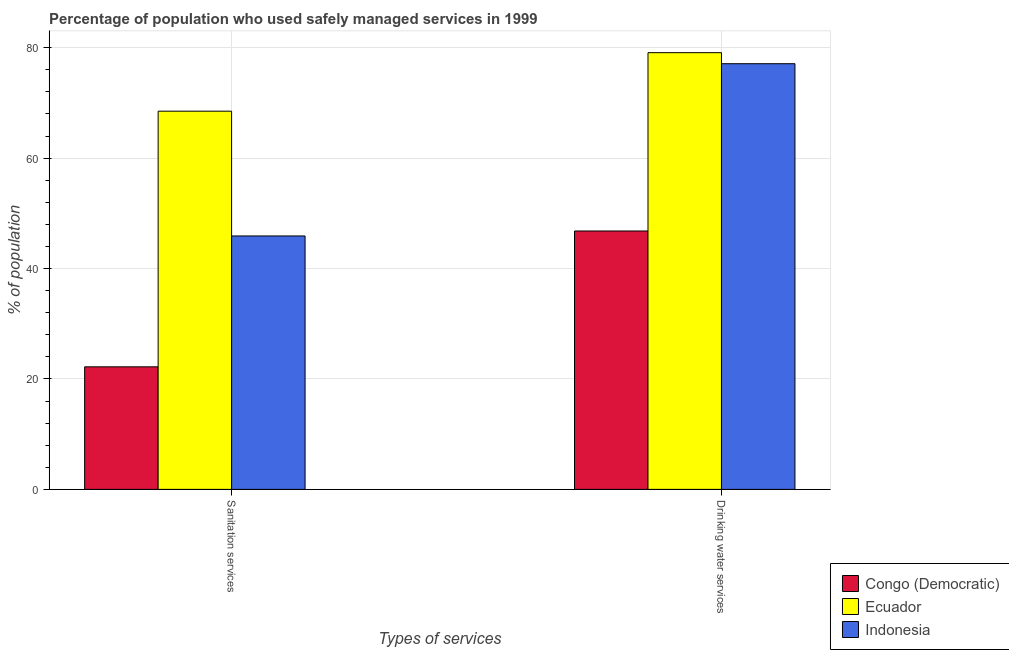How many different coloured bars are there?
Your response must be concise. 3. How many groups of bars are there?
Give a very brief answer. 2. Are the number of bars on each tick of the X-axis equal?
Ensure brevity in your answer.  Yes. What is the label of the 2nd group of bars from the left?
Offer a very short reply. Drinking water services. Across all countries, what is the maximum percentage of population who used drinking water services?
Give a very brief answer. 79.1. Across all countries, what is the minimum percentage of population who used sanitation services?
Offer a terse response. 22.2. In which country was the percentage of population who used drinking water services maximum?
Ensure brevity in your answer.  Ecuador. In which country was the percentage of population who used drinking water services minimum?
Give a very brief answer. Congo (Democratic). What is the total percentage of population who used sanitation services in the graph?
Keep it short and to the point. 136.6. What is the difference between the percentage of population who used sanitation services in Congo (Democratic) and that in Ecuador?
Offer a terse response. -46.3. What is the difference between the percentage of population who used drinking water services in Indonesia and the percentage of population who used sanitation services in Congo (Democratic)?
Ensure brevity in your answer.  54.9. What is the average percentage of population who used sanitation services per country?
Keep it short and to the point. 45.53. What is the difference between the percentage of population who used drinking water services and percentage of population who used sanitation services in Ecuador?
Keep it short and to the point. 10.6. In how many countries, is the percentage of population who used drinking water services greater than 36 %?
Ensure brevity in your answer.  3. What is the ratio of the percentage of population who used drinking water services in Congo (Democratic) to that in Ecuador?
Your answer should be very brief. 0.59. In how many countries, is the percentage of population who used drinking water services greater than the average percentage of population who used drinking water services taken over all countries?
Provide a succinct answer. 2. What does the 2nd bar from the right in Sanitation services represents?
Provide a succinct answer. Ecuador. How many bars are there?
Keep it short and to the point. 6. Are all the bars in the graph horizontal?
Give a very brief answer. No. How many countries are there in the graph?
Make the answer very short. 3. Does the graph contain any zero values?
Give a very brief answer. No. How many legend labels are there?
Provide a succinct answer. 3. How are the legend labels stacked?
Give a very brief answer. Vertical. What is the title of the graph?
Your answer should be very brief. Percentage of population who used safely managed services in 1999. What is the label or title of the X-axis?
Your response must be concise. Types of services. What is the label or title of the Y-axis?
Offer a very short reply. % of population. What is the % of population of Ecuador in Sanitation services?
Keep it short and to the point. 68.5. What is the % of population in Indonesia in Sanitation services?
Your response must be concise. 45.9. What is the % of population of Congo (Democratic) in Drinking water services?
Your answer should be very brief. 46.8. What is the % of population of Ecuador in Drinking water services?
Provide a short and direct response. 79.1. What is the % of population in Indonesia in Drinking water services?
Your answer should be compact. 77.1. Across all Types of services, what is the maximum % of population of Congo (Democratic)?
Give a very brief answer. 46.8. Across all Types of services, what is the maximum % of population of Ecuador?
Provide a succinct answer. 79.1. Across all Types of services, what is the maximum % of population in Indonesia?
Ensure brevity in your answer.  77.1. Across all Types of services, what is the minimum % of population in Ecuador?
Provide a succinct answer. 68.5. Across all Types of services, what is the minimum % of population of Indonesia?
Your answer should be compact. 45.9. What is the total % of population in Ecuador in the graph?
Provide a succinct answer. 147.6. What is the total % of population in Indonesia in the graph?
Your answer should be compact. 123. What is the difference between the % of population in Congo (Democratic) in Sanitation services and that in Drinking water services?
Keep it short and to the point. -24.6. What is the difference between the % of population in Ecuador in Sanitation services and that in Drinking water services?
Provide a short and direct response. -10.6. What is the difference between the % of population of Indonesia in Sanitation services and that in Drinking water services?
Keep it short and to the point. -31.2. What is the difference between the % of population of Congo (Democratic) in Sanitation services and the % of population of Ecuador in Drinking water services?
Your response must be concise. -56.9. What is the difference between the % of population in Congo (Democratic) in Sanitation services and the % of population in Indonesia in Drinking water services?
Your response must be concise. -54.9. What is the average % of population in Congo (Democratic) per Types of services?
Provide a short and direct response. 34.5. What is the average % of population in Ecuador per Types of services?
Your answer should be compact. 73.8. What is the average % of population in Indonesia per Types of services?
Make the answer very short. 61.5. What is the difference between the % of population of Congo (Democratic) and % of population of Ecuador in Sanitation services?
Offer a very short reply. -46.3. What is the difference between the % of population in Congo (Democratic) and % of population in Indonesia in Sanitation services?
Your answer should be very brief. -23.7. What is the difference between the % of population of Ecuador and % of population of Indonesia in Sanitation services?
Make the answer very short. 22.6. What is the difference between the % of population of Congo (Democratic) and % of population of Ecuador in Drinking water services?
Offer a terse response. -32.3. What is the difference between the % of population of Congo (Democratic) and % of population of Indonesia in Drinking water services?
Your response must be concise. -30.3. What is the difference between the % of population in Ecuador and % of population in Indonesia in Drinking water services?
Offer a very short reply. 2. What is the ratio of the % of population of Congo (Democratic) in Sanitation services to that in Drinking water services?
Offer a very short reply. 0.47. What is the ratio of the % of population in Ecuador in Sanitation services to that in Drinking water services?
Provide a short and direct response. 0.87. What is the ratio of the % of population in Indonesia in Sanitation services to that in Drinking water services?
Offer a very short reply. 0.6. What is the difference between the highest and the second highest % of population in Congo (Democratic)?
Provide a succinct answer. 24.6. What is the difference between the highest and the second highest % of population of Ecuador?
Give a very brief answer. 10.6. What is the difference between the highest and the second highest % of population of Indonesia?
Provide a short and direct response. 31.2. What is the difference between the highest and the lowest % of population of Congo (Democratic)?
Your answer should be compact. 24.6. What is the difference between the highest and the lowest % of population of Indonesia?
Provide a succinct answer. 31.2. 